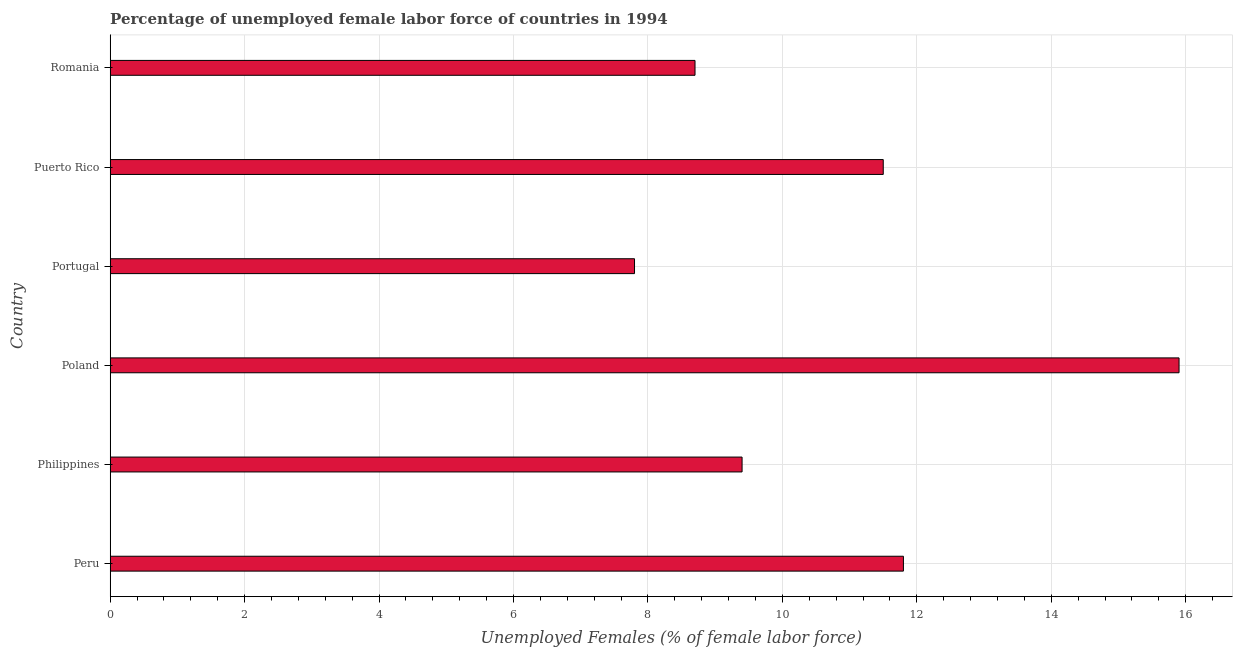What is the title of the graph?
Offer a very short reply. Percentage of unemployed female labor force of countries in 1994. What is the label or title of the X-axis?
Ensure brevity in your answer.  Unemployed Females (% of female labor force). What is the label or title of the Y-axis?
Ensure brevity in your answer.  Country. What is the total unemployed female labour force in Poland?
Your response must be concise. 15.9. Across all countries, what is the maximum total unemployed female labour force?
Provide a short and direct response. 15.9. Across all countries, what is the minimum total unemployed female labour force?
Your answer should be very brief. 7.8. What is the sum of the total unemployed female labour force?
Give a very brief answer. 65.1. What is the average total unemployed female labour force per country?
Your answer should be very brief. 10.85. What is the median total unemployed female labour force?
Keep it short and to the point. 10.45. In how many countries, is the total unemployed female labour force greater than 6.4 %?
Offer a very short reply. 6. What is the ratio of the total unemployed female labour force in Poland to that in Portugal?
Give a very brief answer. 2.04. Is the total unemployed female labour force in Peru less than that in Philippines?
Make the answer very short. No. Is the sum of the total unemployed female labour force in Philippines and Portugal greater than the maximum total unemployed female labour force across all countries?
Provide a succinct answer. Yes. What is the difference between the highest and the lowest total unemployed female labour force?
Offer a very short reply. 8.1. In how many countries, is the total unemployed female labour force greater than the average total unemployed female labour force taken over all countries?
Ensure brevity in your answer.  3. Are all the bars in the graph horizontal?
Offer a terse response. Yes. How many countries are there in the graph?
Your answer should be compact. 6. Are the values on the major ticks of X-axis written in scientific E-notation?
Your response must be concise. No. What is the Unemployed Females (% of female labor force) in Peru?
Your answer should be very brief. 11.8. What is the Unemployed Females (% of female labor force) of Philippines?
Give a very brief answer. 9.4. What is the Unemployed Females (% of female labor force) of Poland?
Provide a succinct answer. 15.9. What is the Unemployed Females (% of female labor force) of Portugal?
Offer a very short reply. 7.8. What is the Unemployed Females (% of female labor force) of Romania?
Give a very brief answer. 8.7. What is the difference between the Unemployed Females (% of female labor force) in Philippines and Poland?
Make the answer very short. -6.5. What is the difference between the Unemployed Females (% of female labor force) in Philippines and Puerto Rico?
Your answer should be very brief. -2.1. What is the difference between the Unemployed Females (% of female labor force) in Poland and Portugal?
Your response must be concise. 8.1. What is the difference between the Unemployed Females (% of female labor force) in Poland and Romania?
Make the answer very short. 7.2. What is the difference between the Unemployed Females (% of female labor force) in Portugal and Puerto Rico?
Provide a short and direct response. -3.7. What is the difference between the Unemployed Females (% of female labor force) in Portugal and Romania?
Give a very brief answer. -0.9. What is the difference between the Unemployed Females (% of female labor force) in Puerto Rico and Romania?
Your response must be concise. 2.8. What is the ratio of the Unemployed Females (% of female labor force) in Peru to that in Philippines?
Provide a succinct answer. 1.25. What is the ratio of the Unemployed Females (% of female labor force) in Peru to that in Poland?
Keep it short and to the point. 0.74. What is the ratio of the Unemployed Females (% of female labor force) in Peru to that in Portugal?
Your answer should be very brief. 1.51. What is the ratio of the Unemployed Females (% of female labor force) in Peru to that in Puerto Rico?
Make the answer very short. 1.03. What is the ratio of the Unemployed Females (% of female labor force) in Peru to that in Romania?
Offer a very short reply. 1.36. What is the ratio of the Unemployed Females (% of female labor force) in Philippines to that in Poland?
Your answer should be compact. 0.59. What is the ratio of the Unemployed Females (% of female labor force) in Philippines to that in Portugal?
Make the answer very short. 1.21. What is the ratio of the Unemployed Females (% of female labor force) in Philippines to that in Puerto Rico?
Your answer should be very brief. 0.82. What is the ratio of the Unemployed Females (% of female labor force) in Philippines to that in Romania?
Provide a succinct answer. 1.08. What is the ratio of the Unemployed Females (% of female labor force) in Poland to that in Portugal?
Make the answer very short. 2.04. What is the ratio of the Unemployed Females (% of female labor force) in Poland to that in Puerto Rico?
Provide a succinct answer. 1.38. What is the ratio of the Unemployed Females (% of female labor force) in Poland to that in Romania?
Offer a terse response. 1.83. What is the ratio of the Unemployed Females (% of female labor force) in Portugal to that in Puerto Rico?
Keep it short and to the point. 0.68. What is the ratio of the Unemployed Females (% of female labor force) in Portugal to that in Romania?
Offer a very short reply. 0.9. What is the ratio of the Unemployed Females (% of female labor force) in Puerto Rico to that in Romania?
Make the answer very short. 1.32. 